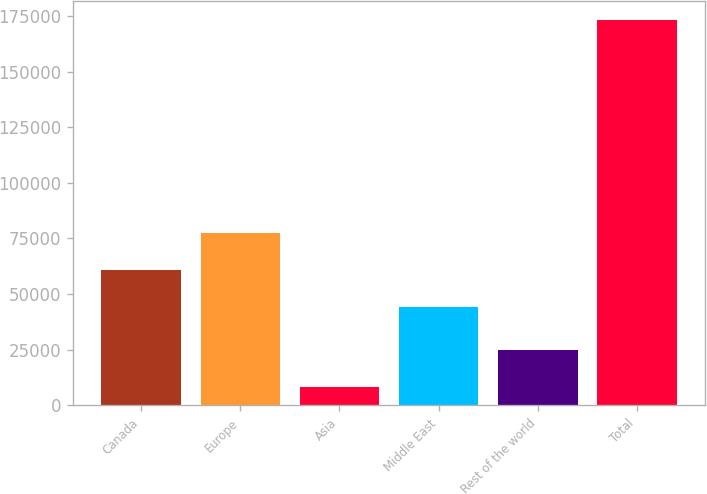<chart> <loc_0><loc_0><loc_500><loc_500><bar_chart><fcel>Canada<fcel>Europe<fcel>Asia<fcel>Middle East<fcel>Rest of the world<fcel>Total<nl><fcel>60839.5<fcel>77338<fcel>8134<fcel>44341<fcel>24632.5<fcel>173119<nl></chart> 